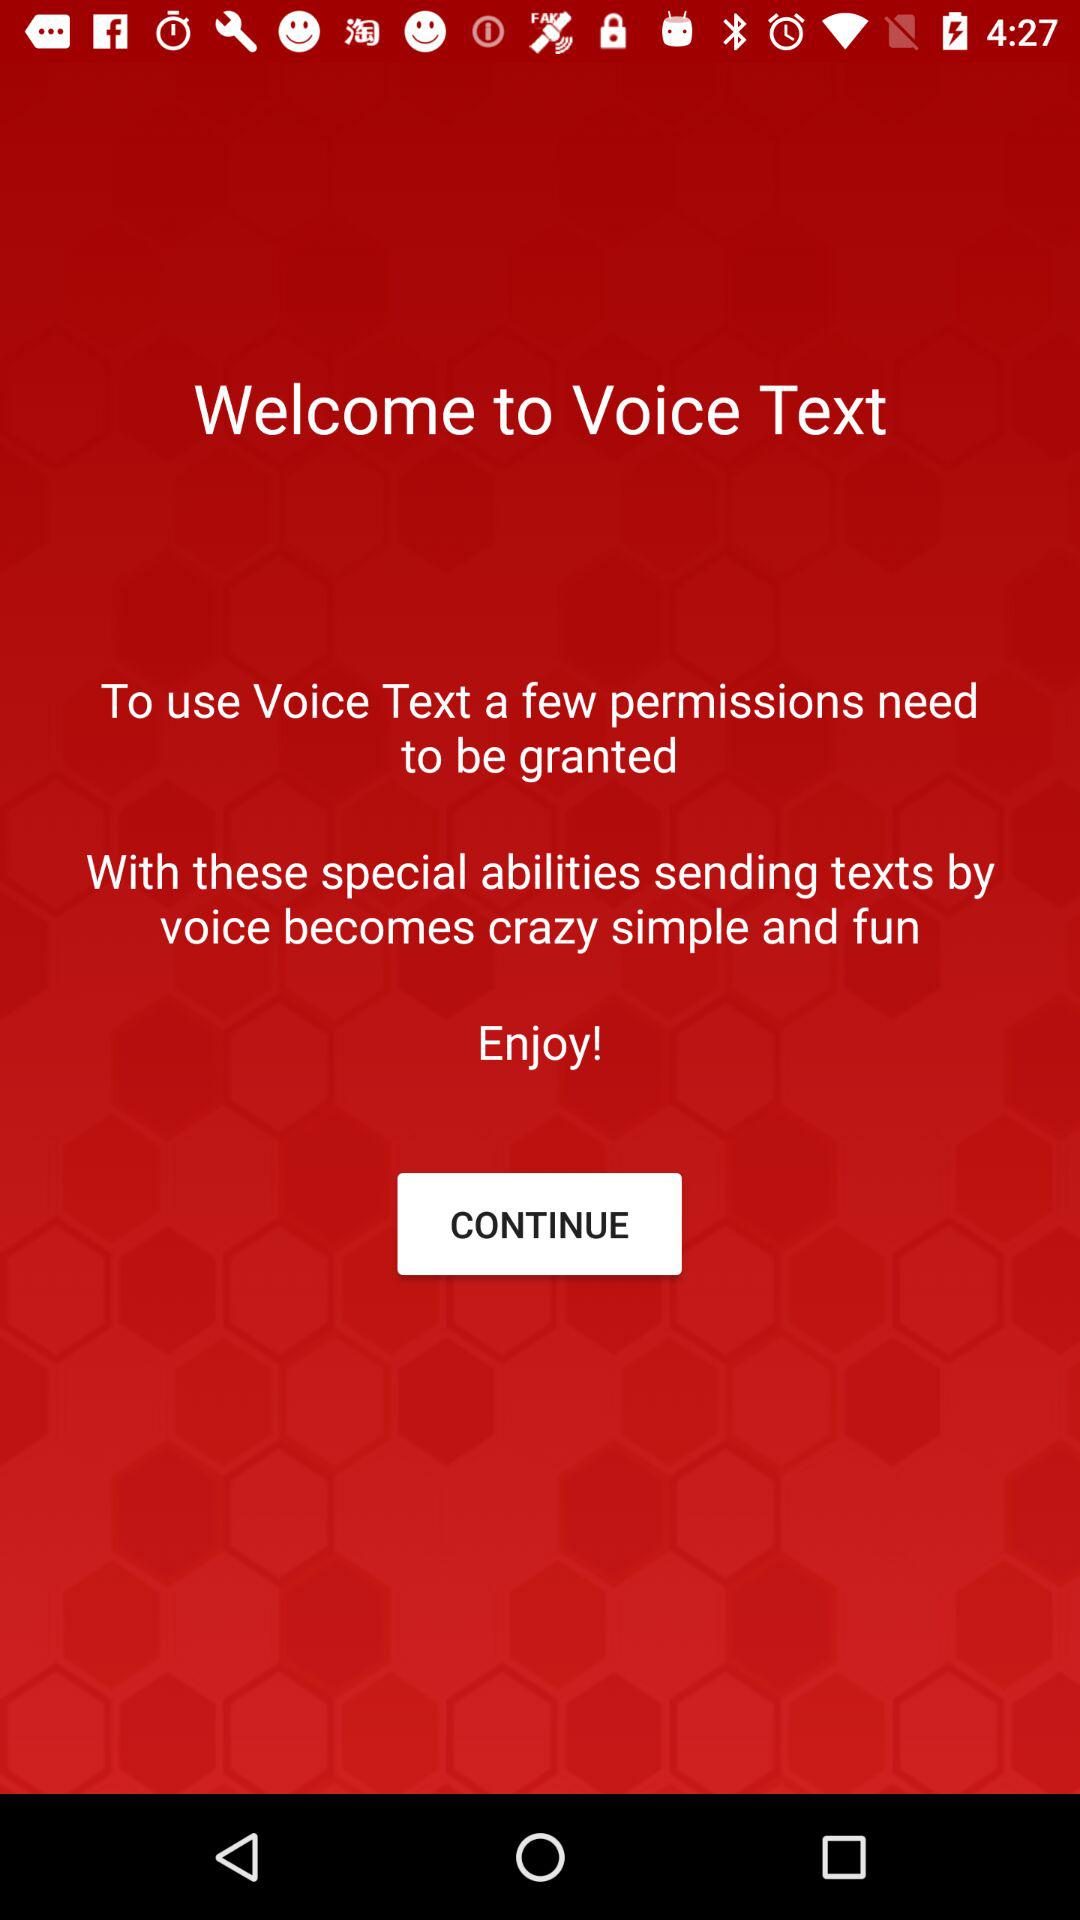What is the name of the application? The name of the application is "Voice Text". 